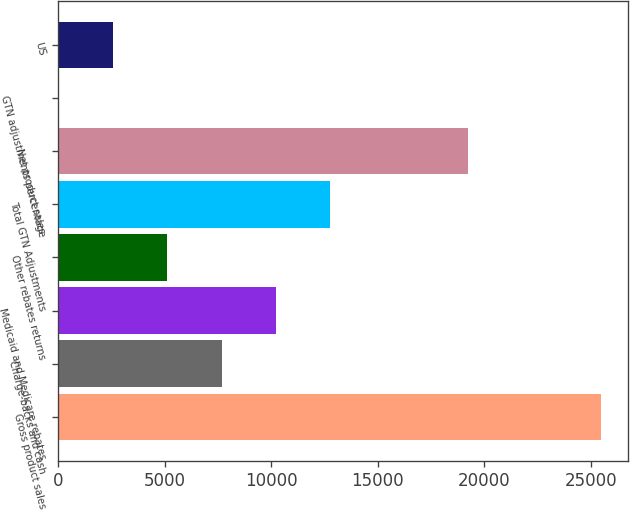<chart> <loc_0><loc_0><loc_500><loc_500><bar_chart><fcel>Gross product sales<fcel>Charge-backs and cash<fcel>Medicaid and Medicare rebates<fcel>Other rebates returns<fcel>Total GTN Adjustments<fcel>Net product sales<fcel>GTN adjustments percentage<fcel>US<nl><fcel>25499<fcel>7666.5<fcel>10214<fcel>5119<fcel>12761.5<fcel>19258<fcel>24<fcel>2571.5<nl></chart> 